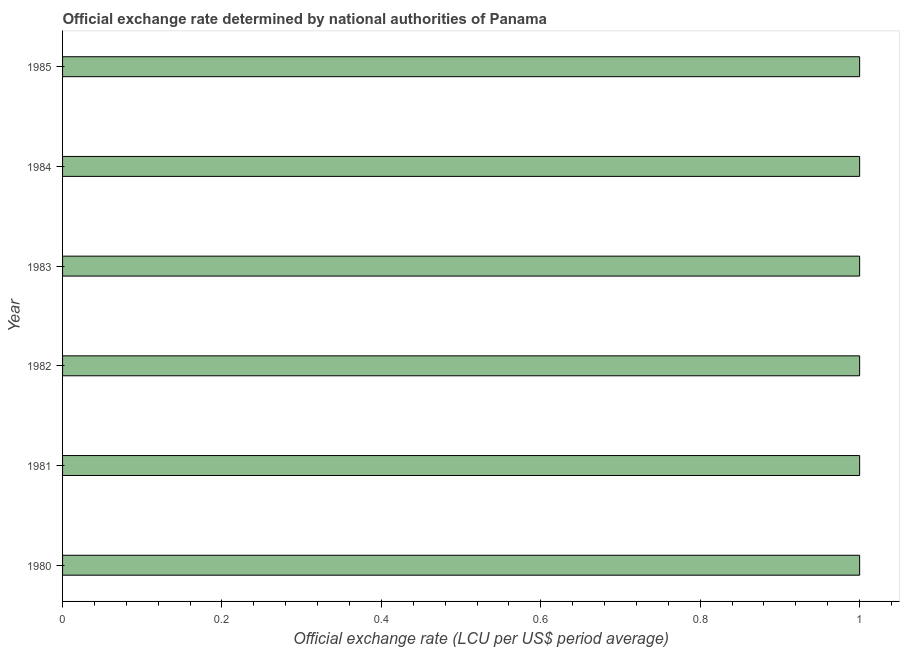Does the graph contain any zero values?
Provide a succinct answer. No. What is the title of the graph?
Your response must be concise. Official exchange rate determined by national authorities of Panama. What is the label or title of the X-axis?
Your answer should be very brief. Official exchange rate (LCU per US$ period average). What is the official exchange rate in 1983?
Offer a very short reply. 1. Across all years, what is the minimum official exchange rate?
Offer a terse response. 1. In which year was the official exchange rate maximum?
Offer a very short reply. 1985. What is the sum of the official exchange rate?
Offer a very short reply. 6. What is the median official exchange rate?
Your answer should be compact. 1. In how many years, is the official exchange rate greater than 0.24 ?
Offer a very short reply. 6. What is the ratio of the official exchange rate in 1982 to that in 1985?
Your answer should be compact. 1. Is the official exchange rate in 1981 less than that in 1985?
Ensure brevity in your answer.  Yes. Is the sum of the official exchange rate in 1981 and 1982 greater than the maximum official exchange rate across all years?
Offer a terse response. Yes. What is the difference between the highest and the lowest official exchange rate?
Make the answer very short. 0. In how many years, is the official exchange rate greater than the average official exchange rate taken over all years?
Make the answer very short. 2. Are all the bars in the graph horizontal?
Your response must be concise. Yes. Are the values on the major ticks of X-axis written in scientific E-notation?
Provide a short and direct response. No. What is the Official exchange rate (LCU per US$ period average) in 1980?
Provide a succinct answer. 1. What is the Official exchange rate (LCU per US$ period average) in 1981?
Give a very brief answer. 1. What is the Official exchange rate (LCU per US$ period average) of 1982?
Offer a terse response. 1. What is the Official exchange rate (LCU per US$ period average) in 1983?
Make the answer very short. 1. What is the Official exchange rate (LCU per US$ period average) in 1984?
Your response must be concise. 1. What is the difference between the Official exchange rate (LCU per US$ period average) in 1980 and 1981?
Your answer should be very brief. 0. What is the difference between the Official exchange rate (LCU per US$ period average) in 1980 and 1984?
Keep it short and to the point. -0. What is the difference between the Official exchange rate (LCU per US$ period average) in 1981 and 1982?
Your answer should be very brief. 0. What is the difference between the Official exchange rate (LCU per US$ period average) in 1981 and 1984?
Offer a terse response. -0. What is the difference between the Official exchange rate (LCU per US$ period average) in 1981 and 1985?
Provide a succinct answer. -0. What is the difference between the Official exchange rate (LCU per US$ period average) in 1984 and 1985?
Ensure brevity in your answer.  -0. What is the ratio of the Official exchange rate (LCU per US$ period average) in 1980 to that in 1981?
Ensure brevity in your answer.  1. What is the ratio of the Official exchange rate (LCU per US$ period average) in 1980 to that in 1982?
Offer a very short reply. 1. What is the ratio of the Official exchange rate (LCU per US$ period average) in 1980 to that in 1985?
Your answer should be very brief. 1. What is the ratio of the Official exchange rate (LCU per US$ period average) in 1981 to that in 1982?
Provide a succinct answer. 1. What is the ratio of the Official exchange rate (LCU per US$ period average) in 1981 to that in 1983?
Provide a short and direct response. 1. What is the ratio of the Official exchange rate (LCU per US$ period average) in 1981 to that in 1984?
Give a very brief answer. 1. What is the ratio of the Official exchange rate (LCU per US$ period average) in 1982 to that in 1983?
Keep it short and to the point. 1. What is the ratio of the Official exchange rate (LCU per US$ period average) in 1982 to that in 1984?
Provide a succinct answer. 1. What is the ratio of the Official exchange rate (LCU per US$ period average) in 1983 to that in 1984?
Keep it short and to the point. 1. What is the ratio of the Official exchange rate (LCU per US$ period average) in 1983 to that in 1985?
Provide a succinct answer. 1. 